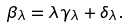Convert formula to latex. <formula><loc_0><loc_0><loc_500><loc_500>\beta _ { \lambda } = \lambda \gamma _ { \lambda } + \delta _ { \lambda } .</formula> 